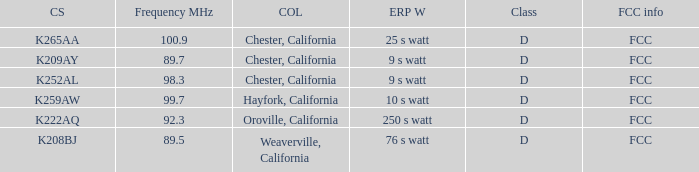Name the sum of frequency will call sign of k259aw 99.7. 